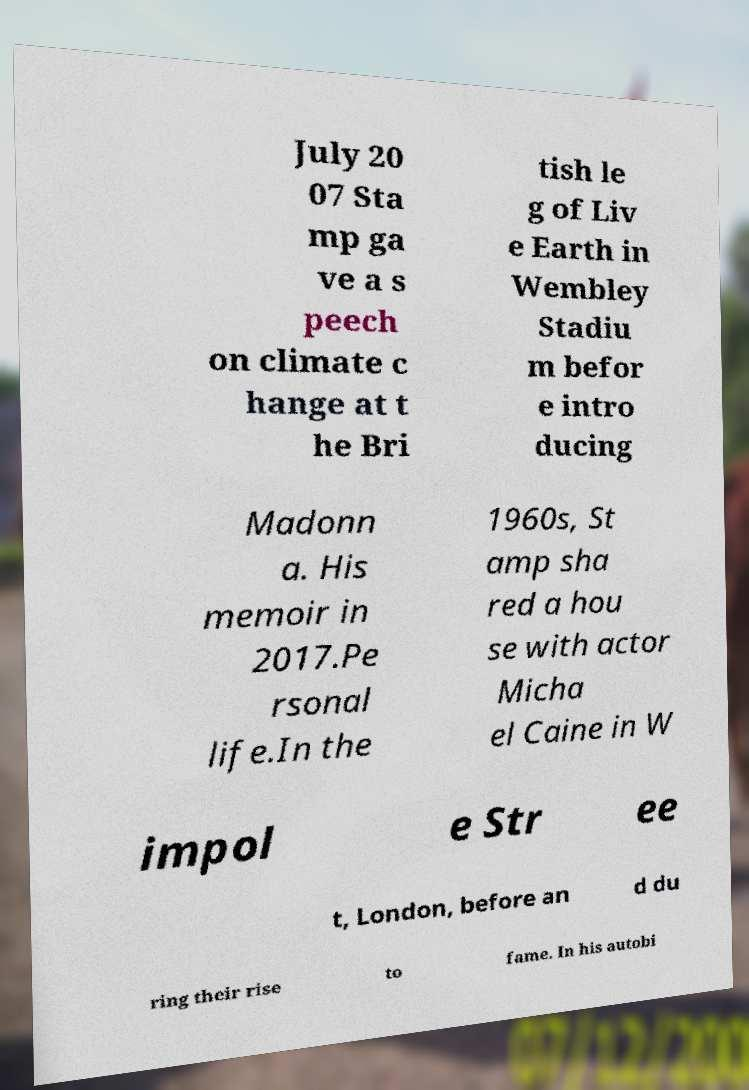Could you extract and type out the text from this image? July 20 07 Sta mp ga ve a s peech on climate c hange at t he Bri tish le g of Liv e Earth in Wembley Stadiu m befor e intro ducing Madonn a. His memoir in 2017.Pe rsonal life.In the 1960s, St amp sha red a hou se with actor Micha el Caine in W impol e Str ee t, London, before an d du ring their rise to fame. In his autobi 